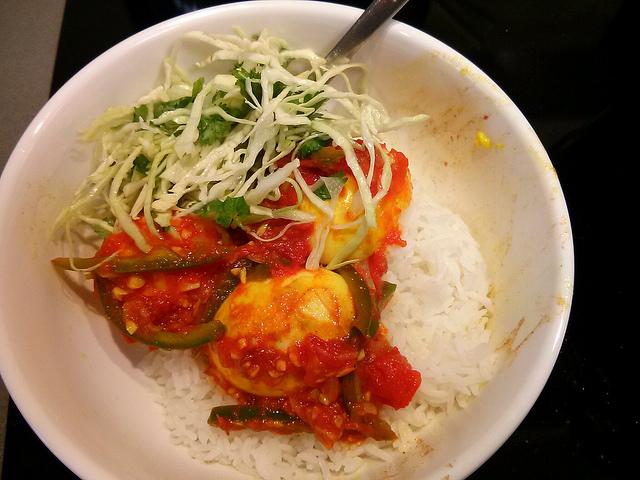Does this look like oriental cuisine?
Be succinct. Yes. What color is the bowl?
Keep it brief. White. Is this soup?
Answer briefly. No. The meal does not?
Short answer required. No. 